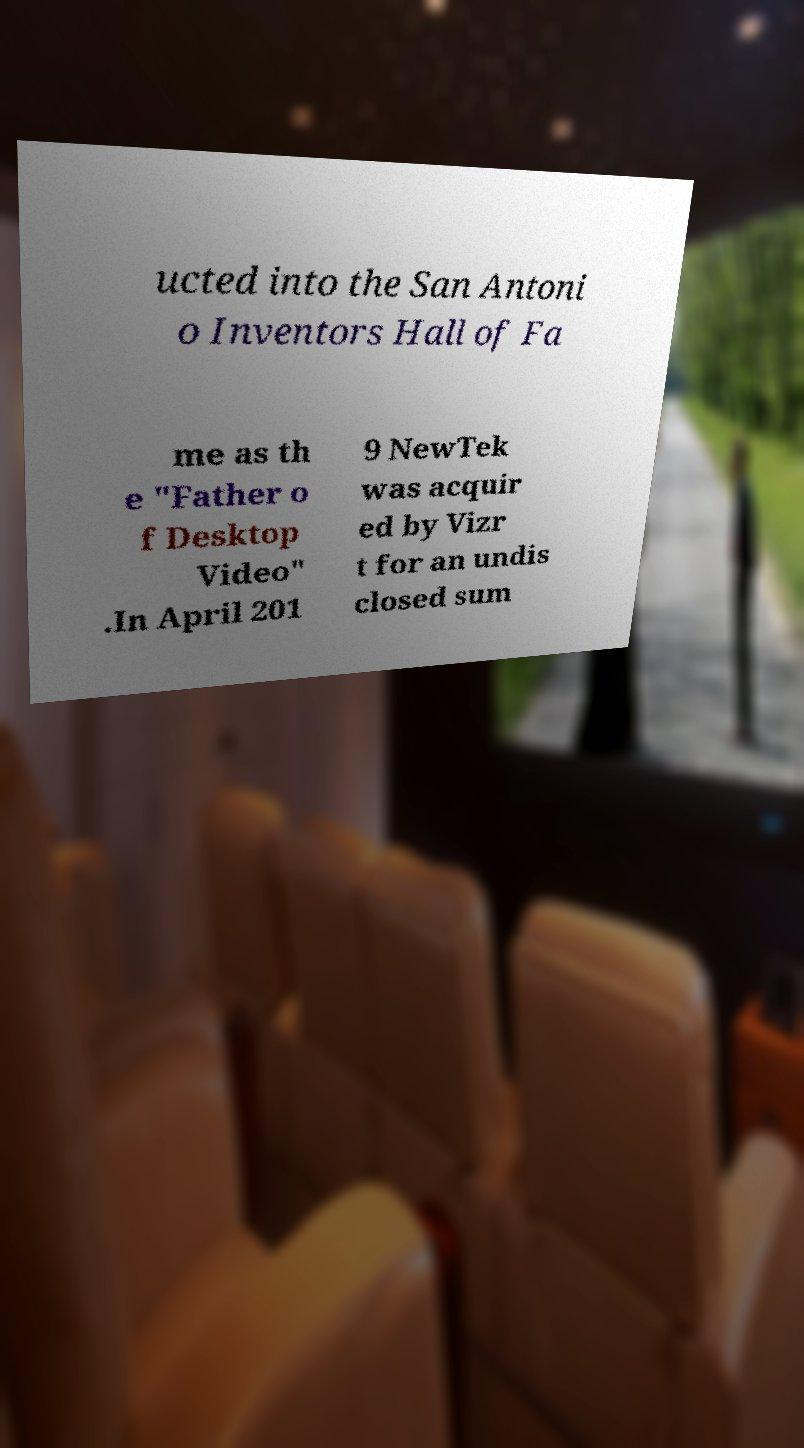Please identify and transcribe the text found in this image. ucted into the San Antoni o Inventors Hall of Fa me as th e "Father o f Desktop Video" .In April 201 9 NewTek was acquir ed by Vizr t for an undis closed sum 